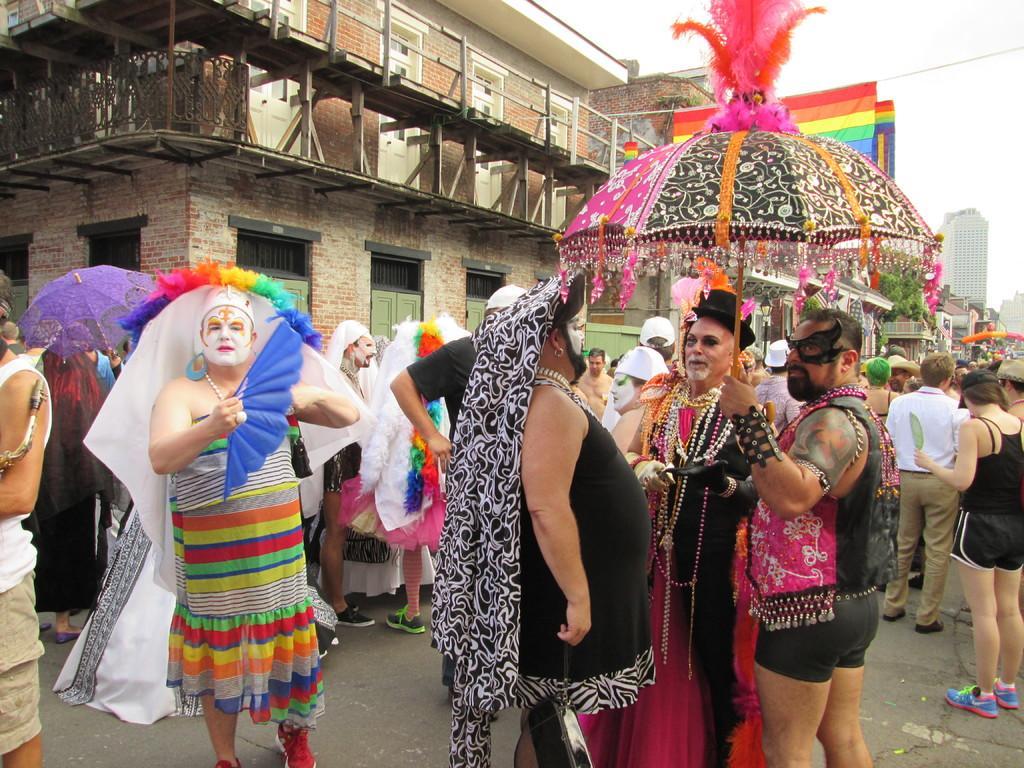In one or two sentences, can you explain what this image depicts? Here we can see crowd. These people are holding umbrellas. Background there are buildings. 